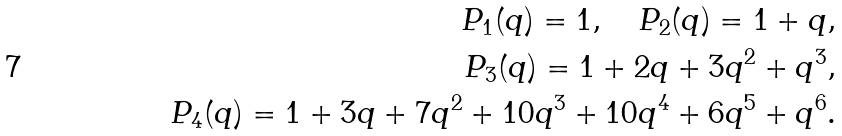Convert formula to latex. <formula><loc_0><loc_0><loc_500><loc_500>P _ { 1 } ( q ) = 1 , \quad P _ { 2 } ( q ) = 1 + q , \\ P _ { 3 } ( q ) = 1 + 2 q + 3 q ^ { 2 } + q ^ { 3 } , \\ P _ { 4 } ( q ) = 1 + 3 q + 7 q ^ { 2 } + 1 0 q ^ { 3 } + 1 0 q ^ { 4 } + 6 q ^ { 5 } + q ^ { 6 } .</formula> 